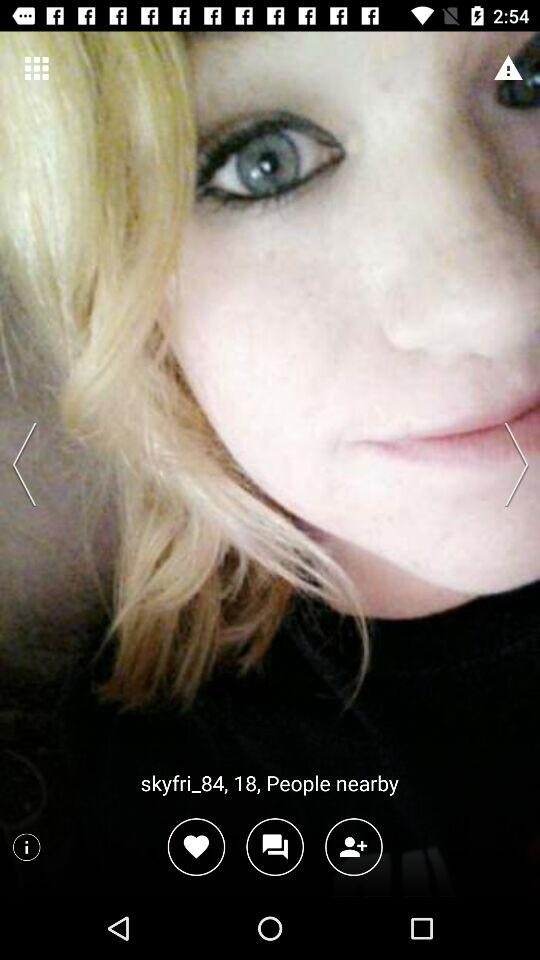How many people are nearby?
Answer the question using a single word or phrase. 18 